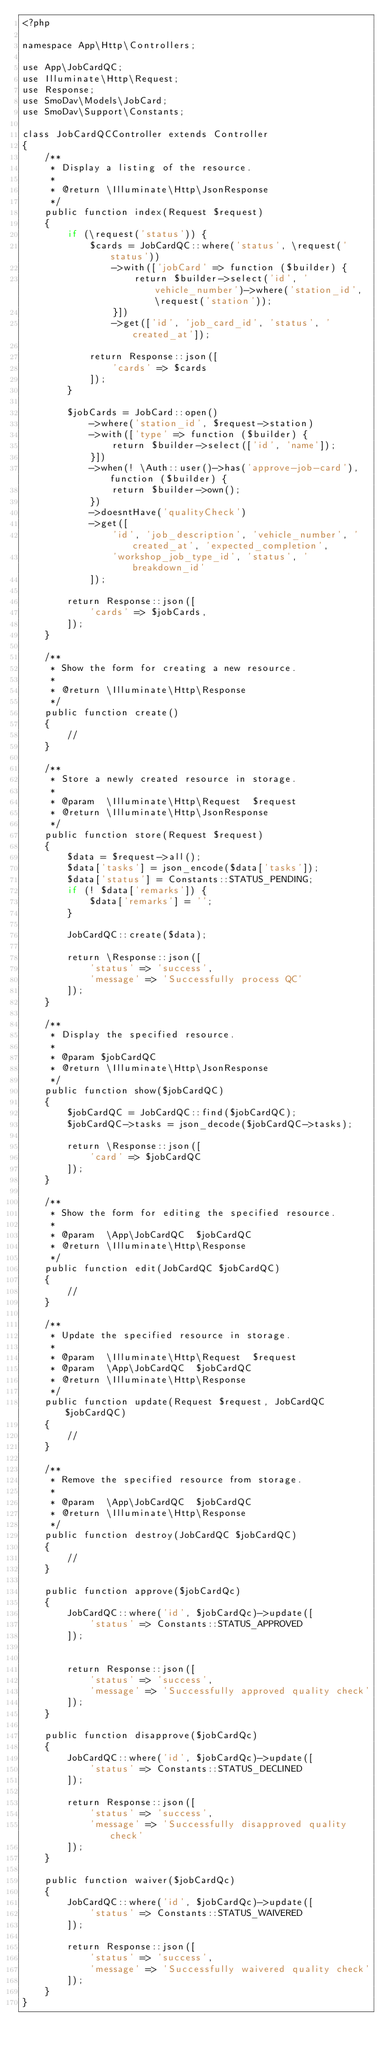Convert code to text. <code><loc_0><loc_0><loc_500><loc_500><_PHP_><?php

namespace App\Http\Controllers;

use App\JobCardQC;
use Illuminate\Http\Request;
use Response;
use SmoDav\Models\JobCard;
use SmoDav\Support\Constants;

class JobCardQCController extends Controller
{
    /**
     * Display a listing of the resource.
     *
     * @return \Illuminate\Http\JsonResponse
     */
    public function index(Request $request)
    {
        if (\request('status')) {
            $cards = JobCardQC::where('status', \request('status'))
                ->with(['jobCard' => function ($builder) {
                    return $builder->select('id', 'vehicle_number')->where('station_id', \request('station'));
                }])
                ->get(['id', 'job_card_id', 'status', 'created_at']);

            return Response::json([
                'cards' => $cards
            ]);
        }

        $jobCards = JobCard::open()
            ->where('station_id', $request->station)
            ->with(['type' => function ($builder) {
                return $builder->select(['id', 'name']);
            }])
            ->when(! \Auth::user()->has('approve-job-card'), function ($builder) {
                return $builder->own();
            })
            ->doesntHave('qualityCheck')
            ->get([
                'id', 'job_description', 'vehicle_number', 'created_at', 'expected_completion',
                'workshop_job_type_id', 'status', 'breakdown_id'
            ]);

        return Response::json([
            'cards' => $jobCards,
        ]);
    }

    /**
     * Show the form for creating a new resource.
     *
     * @return \Illuminate\Http\Response
     */
    public function create()
    {
        //
    }

    /**
     * Store a newly created resource in storage.
     *
     * @param  \Illuminate\Http\Request  $request
     * @return \Illuminate\Http\JsonResponse
     */
    public function store(Request $request)
    {
        $data = $request->all();
        $data['tasks'] = json_encode($data['tasks']);
        $data['status'] = Constants::STATUS_PENDING;
        if (! $data['remarks']) {
            $data['remarks'] = '';
        }

        JobCardQC::create($data);

        return \Response::json([
            'status' => 'success',
            'message' => 'Successfully process QC'
        ]);
    }

    /**
     * Display the specified resource.
     *
     * @param $jobCardQC
     * @return \Illuminate\Http\JsonResponse
     */
    public function show($jobCardQC)
    {
        $jobCardQC = JobCardQC::find($jobCardQC);
        $jobCardQC->tasks = json_decode($jobCardQC->tasks);

        return \Response::json([
            'card' => $jobCardQC
        ]);
    }

    /**
     * Show the form for editing the specified resource.
     *
     * @param  \App\JobCardQC  $jobCardQC
     * @return \Illuminate\Http\Response
     */
    public function edit(JobCardQC $jobCardQC)
    {
        //
    }

    /**
     * Update the specified resource in storage.
     *
     * @param  \Illuminate\Http\Request  $request
     * @param  \App\JobCardQC  $jobCardQC
     * @return \Illuminate\Http\Response
     */
    public function update(Request $request, JobCardQC $jobCardQC)
    {
        //
    }

    /**
     * Remove the specified resource from storage.
     *
     * @param  \App\JobCardQC  $jobCardQC
     * @return \Illuminate\Http\Response
     */
    public function destroy(JobCardQC $jobCardQC)
    {
        //
    }

    public function approve($jobCardQc)
    {
        JobCardQC::where('id', $jobCardQc)->update([
            'status' => Constants::STATUS_APPROVED
        ]);


        return Response::json([
            'status' => 'success',
            'message' => 'Successfully approved quality check'
        ]);
    }

    public function disapprove($jobCardQc)
    {
        JobCardQC::where('id', $jobCardQc)->update([
            'status' => Constants::STATUS_DECLINED
        ]);

        return Response::json([
            'status' => 'success',
            'message' => 'Successfully disapproved quality check'
        ]);
    }

    public function waiver($jobCardQc)
    {
        JobCardQC::where('id', $jobCardQc)->update([
            'status' => Constants::STATUS_WAIVERED
        ]);

        return Response::json([
            'status' => 'success',
            'message' => 'Successfully waivered quality check'
        ]);
    }
}
</code> 